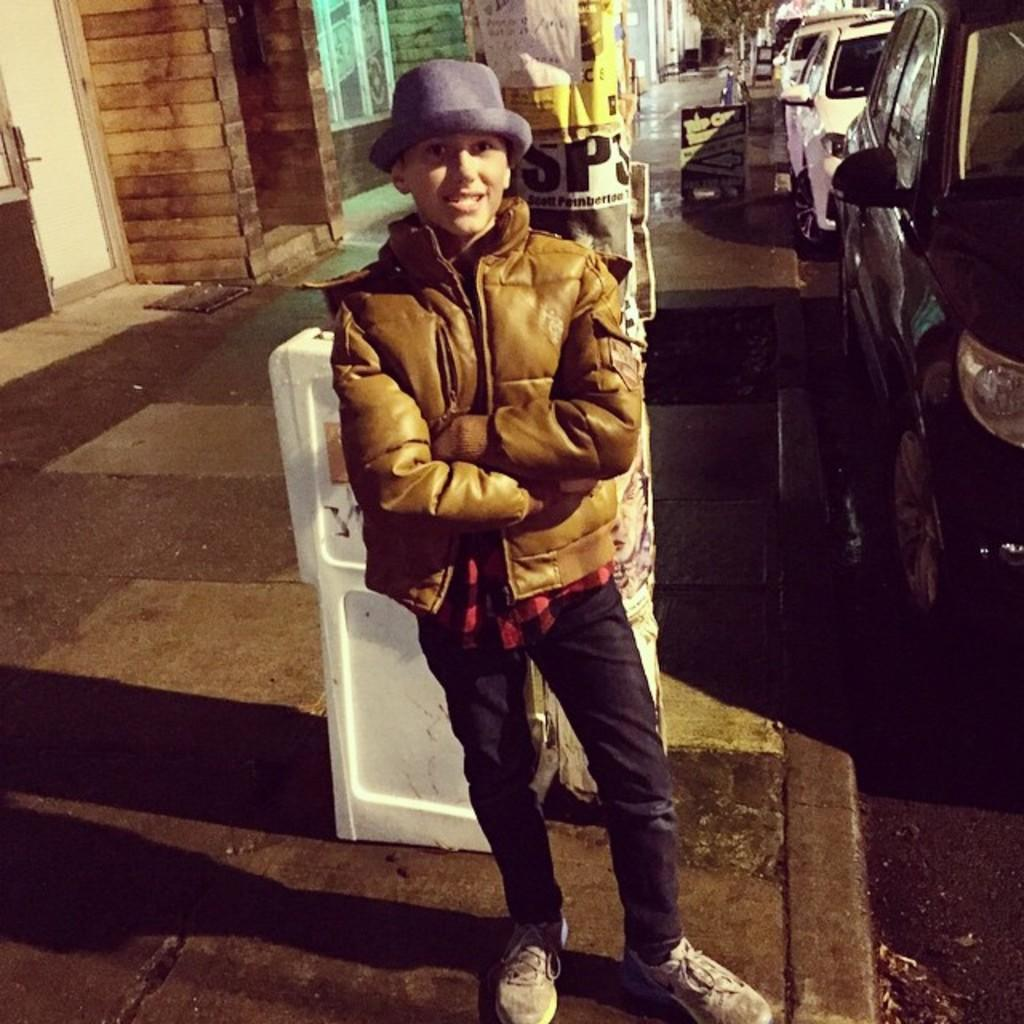Who is the main subject in the image? There is a boy in the image. What is the boy wearing? The boy is wearing a jacket and a hat. What can be seen on the road in the image? There are vehicles on the road in the image. What is visible in the background of the image? There is a building in the background of the image. What type of insect can be seen crawling on the boy's throat in the image? There is no insect present on the boy's throat in the image. Who is assisting the boy with his luggage in the image? There is no porter present in the image to assist the boy with his luggage. 